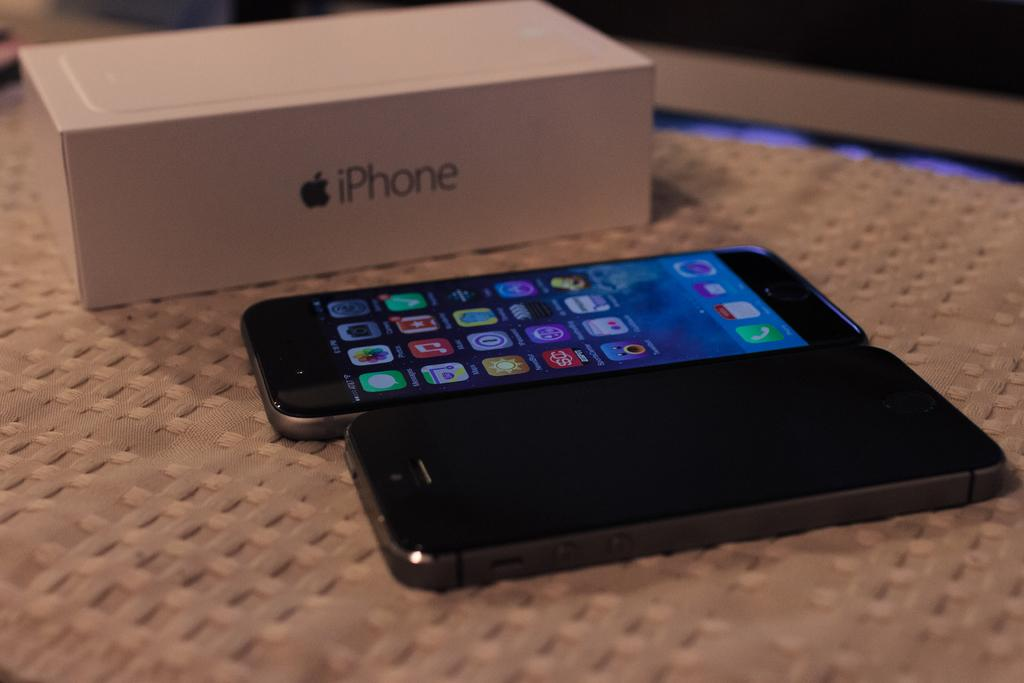<image>
Present a compact description of the photo's key features. Two cell phones are sitting near a white iPhone box. 